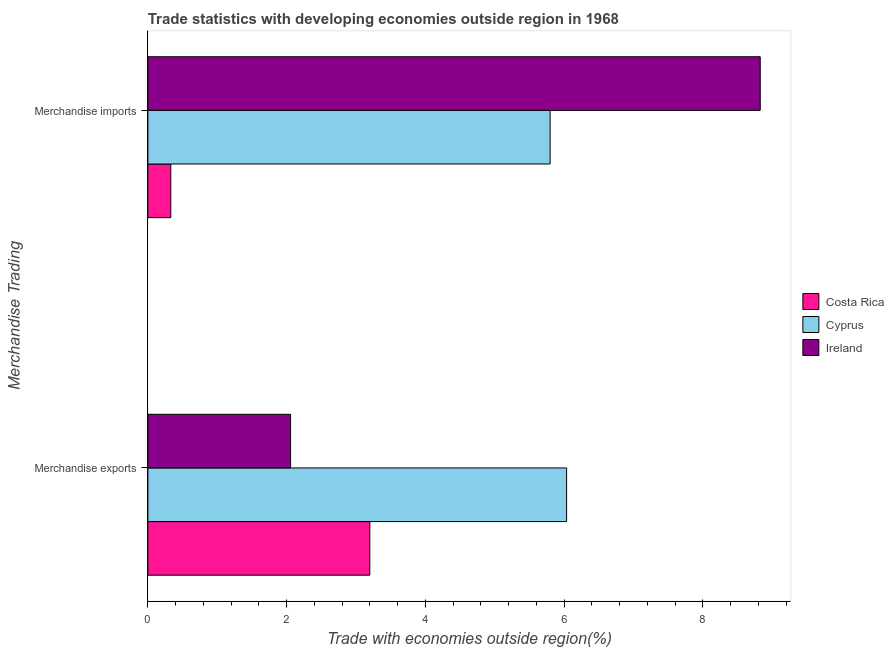How many groups of bars are there?
Offer a very short reply. 2. Are the number of bars per tick equal to the number of legend labels?
Keep it short and to the point. Yes. Are the number of bars on each tick of the Y-axis equal?
Offer a terse response. Yes. How many bars are there on the 1st tick from the top?
Offer a very short reply. 3. How many bars are there on the 1st tick from the bottom?
Offer a very short reply. 3. What is the merchandise exports in Ireland?
Give a very brief answer. 2.06. Across all countries, what is the maximum merchandise imports?
Ensure brevity in your answer.  8.83. Across all countries, what is the minimum merchandise exports?
Offer a very short reply. 2.06. In which country was the merchandise imports maximum?
Offer a terse response. Ireland. What is the total merchandise exports in the graph?
Offer a terse response. 11.29. What is the difference between the merchandise imports in Cyprus and that in Ireland?
Offer a very short reply. -3.03. What is the difference between the merchandise imports in Ireland and the merchandise exports in Cyprus?
Your answer should be compact. 2.79. What is the average merchandise imports per country?
Provide a short and direct response. 4.99. What is the difference between the merchandise exports and merchandise imports in Costa Rica?
Offer a terse response. 2.87. What is the ratio of the merchandise imports in Cyprus to that in Costa Rica?
Offer a very short reply. 17.55. What does the 3rd bar from the top in Merchandise imports represents?
Give a very brief answer. Costa Rica. What does the 2nd bar from the bottom in Merchandise exports represents?
Ensure brevity in your answer.  Cyprus. How many countries are there in the graph?
Your answer should be compact. 3. Are the values on the major ticks of X-axis written in scientific E-notation?
Make the answer very short. No. Does the graph contain any zero values?
Offer a terse response. No. Does the graph contain grids?
Keep it short and to the point. No. Where does the legend appear in the graph?
Your answer should be very brief. Center right. How are the legend labels stacked?
Make the answer very short. Vertical. What is the title of the graph?
Offer a very short reply. Trade statistics with developing economies outside region in 1968. What is the label or title of the X-axis?
Provide a succinct answer. Trade with economies outside region(%). What is the label or title of the Y-axis?
Offer a very short reply. Merchandise Trading. What is the Trade with economies outside region(%) in Costa Rica in Merchandise exports?
Make the answer very short. 3.2. What is the Trade with economies outside region(%) of Cyprus in Merchandise exports?
Provide a short and direct response. 6.04. What is the Trade with economies outside region(%) in Ireland in Merchandise exports?
Make the answer very short. 2.06. What is the Trade with economies outside region(%) in Costa Rica in Merchandise imports?
Keep it short and to the point. 0.33. What is the Trade with economies outside region(%) in Cyprus in Merchandise imports?
Provide a short and direct response. 5.8. What is the Trade with economies outside region(%) of Ireland in Merchandise imports?
Give a very brief answer. 8.83. Across all Merchandise Trading, what is the maximum Trade with economies outside region(%) of Costa Rica?
Offer a terse response. 3.2. Across all Merchandise Trading, what is the maximum Trade with economies outside region(%) of Cyprus?
Provide a short and direct response. 6.04. Across all Merchandise Trading, what is the maximum Trade with economies outside region(%) in Ireland?
Ensure brevity in your answer.  8.83. Across all Merchandise Trading, what is the minimum Trade with economies outside region(%) in Costa Rica?
Offer a terse response. 0.33. Across all Merchandise Trading, what is the minimum Trade with economies outside region(%) in Cyprus?
Your answer should be very brief. 5.8. Across all Merchandise Trading, what is the minimum Trade with economies outside region(%) of Ireland?
Provide a succinct answer. 2.06. What is the total Trade with economies outside region(%) in Costa Rica in the graph?
Offer a very short reply. 3.53. What is the total Trade with economies outside region(%) of Cyprus in the graph?
Make the answer very short. 11.84. What is the total Trade with economies outside region(%) in Ireland in the graph?
Keep it short and to the point. 10.88. What is the difference between the Trade with economies outside region(%) of Costa Rica in Merchandise exports and that in Merchandise imports?
Give a very brief answer. 2.87. What is the difference between the Trade with economies outside region(%) of Cyprus in Merchandise exports and that in Merchandise imports?
Keep it short and to the point. 0.24. What is the difference between the Trade with economies outside region(%) of Ireland in Merchandise exports and that in Merchandise imports?
Provide a succinct answer. -6.77. What is the difference between the Trade with economies outside region(%) in Costa Rica in Merchandise exports and the Trade with economies outside region(%) in Cyprus in Merchandise imports?
Give a very brief answer. -2.6. What is the difference between the Trade with economies outside region(%) of Costa Rica in Merchandise exports and the Trade with economies outside region(%) of Ireland in Merchandise imports?
Keep it short and to the point. -5.63. What is the difference between the Trade with economies outside region(%) of Cyprus in Merchandise exports and the Trade with economies outside region(%) of Ireland in Merchandise imports?
Offer a terse response. -2.79. What is the average Trade with economies outside region(%) of Costa Rica per Merchandise Trading?
Offer a very short reply. 1.76. What is the average Trade with economies outside region(%) in Cyprus per Merchandise Trading?
Make the answer very short. 5.92. What is the average Trade with economies outside region(%) in Ireland per Merchandise Trading?
Your answer should be compact. 5.44. What is the difference between the Trade with economies outside region(%) in Costa Rica and Trade with economies outside region(%) in Cyprus in Merchandise exports?
Give a very brief answer. -2.84. What is the difference between the Trade with economies outside region(%) of Costa Rica and Trade with economies outside region(%) of Ireland in Merchandise exports?
Provide a short and direct response. 1.14. What is the difference between the Trade with economies outside region(%) of Cyprus and Trade with economies outside region(%) of Ireland in Merchandise exports?
Offer a terse response. 3.98. What is the difference between the Trade with economies outside region(%) of Costa Rica and Trade with economies outside region(%) of Cyprus in Merchandise imports?
Your answer should be very brief. -5.47. What is the difference between the Trade with economies outside region(%) of Costa Rica and Trade with economies outside region(%) of Ireland in Merchandise imports?
Offer a very short reply. -8.5. What is the difference between the Trade with economies outside region(%) of Cyprus and Trade with economies outside region(%) of Ireland in Merchandise imports?
Keep it short and to the point. -3.03. What is the ratio of the Trade with economies outside region(%) of Costa Rica in Merchandise exports to that in Merchandise imports?
Offer a very short reply. 9.68. What is the ratio of the Trade with economies outside region(%) of Cyprus in Merchandise exports to that in Merchandise imports?
Provide a short and direct response. 1.04. What is the ratio of the Trade with economies outside region(%) of Ireland in Merchandise exports to that in Merchandise imports?
Your answer should be very brief. 0.23. What is the difference between the highest and the second highest Trade with economies outside region(%) in Costa Rica?
Provide a short and direct response. 2.87. What is the difference between the highest and the second highest Trade with economies outside region(%) of Cyprus?
Your answer should be compact. 0.24. What is the difference between the highest and the second highest Trade with economies outside region(%) of Ireland?
Keep it short and to the point. 6.77. What is the difference between the highest and the lowest Trade with economies outside region(%) of Costa Rica?
Provide a succinct answer. 2.87. What is the difference between the highest and the lowest Trade with economies outside region(%) in Cyprus?
Make the answer very short. 0.24. What is the difference between the highest and the lowest Trade with economies outside region(%) in Ireland?
Provide a short and direct response. 6.77. 